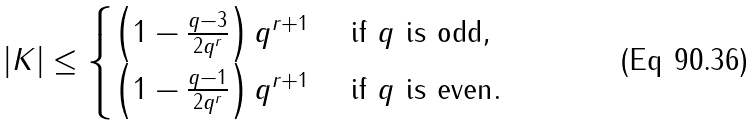<formula> <loc_0><loc_0><loc_500><loc_500>| K | \leq \begin{cases} \left ( 1 - \frac { q - 3 } { 2 q ^ { r } } \right ) q ^ { r + 1 } & \text { if $q$ is odd} , \\ \left ( 1 - \frac { q - 1 } { 2 q ^ { r } } \right ) q ^ { r + 1 } & \text { if $q$ is even} . \end{cases}</formula> 